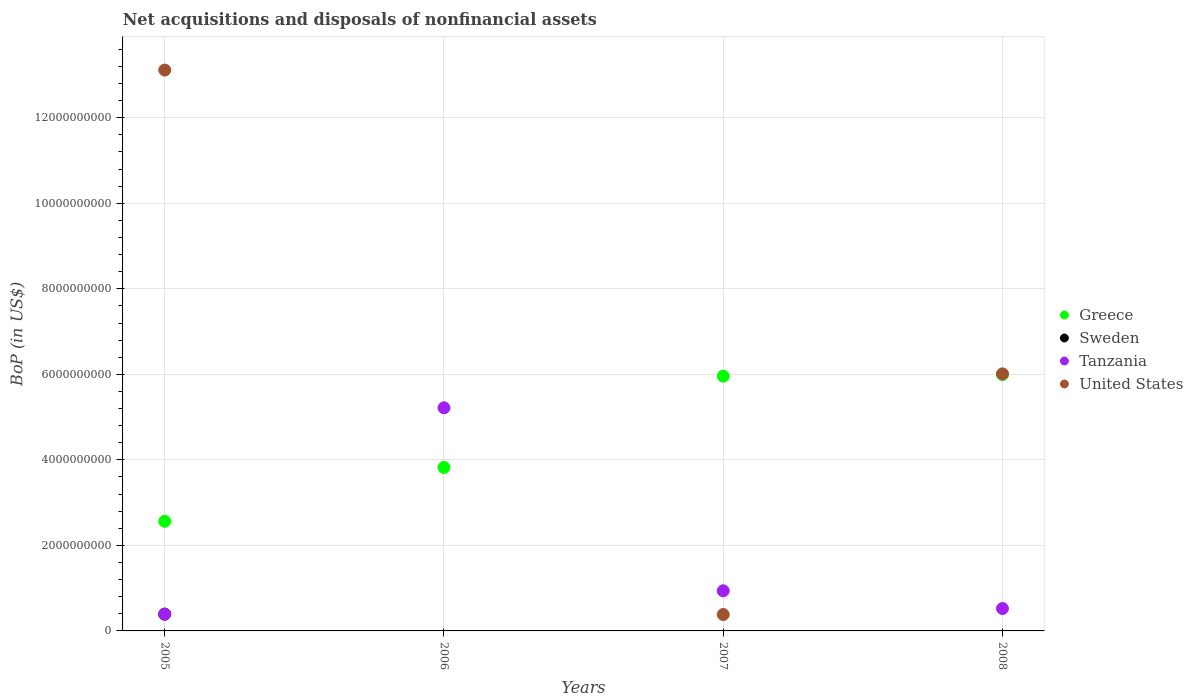How many different coloured dotlines are there?
Make the answer very short. 4. Is the number of dotlines equal to the number of legend labels?
Provide a succinct answer. No. What is the Balance of Payments in Greece in 2007?
Provide a succinct answer. 5.96e+09. Across all years, what is the maximum Balance of Payments in Tanzania?
Ensure brevity in your answer.  5.22e+09. Across all years, what is the minimum Balance of Payments in Sweden?
Your answer should be very brief. 0. In which year was the Balance of Payments in United States maximum?
Make the answer very short. 2005. What is the total Balance of Payments in Greece in the graph?
Your response must be concise. 1.83e+1. What is the difference between the Balance of Payments in Greece in 2006 and that in 2008?
Ensure brevity in your answer.  -2.17e+09. What is the difference between the Balance of Payments in Tanzania in 2006 and the Balance of Payments in Greece in 2007?
Provide a short and direct response. -7.39e+08. What is the average Balance of Payments in Greece per year?
Give a very brief answer. 4.58e+09. In the year 2008, what is the difference between the Balance of Payments in Greece and Balance of Payments in United States?
Your response must be concise. -1.59e+07. In how many years, is the Balance of Payments in Tanzania greater than 6800000000 US$?
Offer a very short reply. 0. What is the ratio of the Balance of Payments in Greece in 2005 to that in 2007?
Ensure brevity in your answer.  0.43. What is the difference between the highest and the second highest Balance of Payments in Greece?
Your response must be concise. 3.82e+07. What is the difference between the highest and the lowest Balance of Payments in United States?
Offer a very short reply. 1.31e+1. In how many years, is the Balance of Payments in Tanzania greater than the average Balance of Payments in Tanzania taken over all years?
Your response must be concise. 1. Is it the case that in every year, the sum of the Balance of Payments in Tanzania and Balance of Payments in Greece  is greater than the Balance of Payments in United States?
Offer a very short reply. No. Is the Balance of Payments in United States strictly greater than the Balance of Payments in Sweden over the years?
Offer a terse response. Yes. What is the difference between two consecutive major ticks on the Y-axis?
Provide a succinct answer. 2.00e+09. Where does the legend appear in the graph?
Provide a short and direct response. Center right. What is the title of the graph?
Offer a terse response. Net acquisitions and disposals of nonfinancial assets. What is the label or title of the Y-axis?
Offer a very short reply. BoP (in US$). What is the BoP (in US$) in Greece in 2005?
Offer a terse response. 2.56e+09. What is the BoP (in US$) in Sweden in 2005?
Keep it short and to the point. 3.92e+08. What is the BoP (in US$) of Tanzania in 2005?
Your response must be concise. 3.93e+08. What is the BoP (in US$) in United States in 2005?
Offer a terse response. 1.31e+1. What is the BoP (in US$) in Greece in 2006?
Make the answer very short. 3.82e+09. What is the BoP (in US$) in Sweden in 2006?
Offer a very short reply. 0. What is the BoP (in US$) in Tanzania in 2006?
Your answer should be very brief. 5.22e+09. What is the BoP (in US$) in United States in 2006?
Provide a short and direct response. 0. What is the BoP (in US$) of Greece in 2007?
Make the answer very short. 5.96e+09. What is the BoP (in US$) in Sweden in 2007?
Offer a very short reply. 0. What is the BoP (in US$) of Tanzania in 2007?
Your response must be concise. 9.39e+08. What is the BoP (in US$) in United States in 2007?
Offer a terse response. 3.84e+08. What is the BoP (in US$) in Greece in 2008?
Offer a terse response. 6.00e+09. What is the BoP (in US$) in Sweden in 2008?
Provide a short and direct response. 0. What is the BoP (in US$) in Tanzania in 2008?
Offer a terse response. 5.24e+08. What is the BoP (in US$) in United States in 2008?
Provide a succinct answer. 6.01e+09. Across all years, what is the maximum BoP (in US$) of Greece?
Make the answer very short. 6.00e+09. Across all years, what is the maximum BoP (in US$) of Sweden?
Your answer should be compact. 3.92e+08. Across all years, what is the maximum BoP (in US$) in Tanzania?
Offer a terse response. 5.22e+09. Across all years, what is the maximum BoP (in US$) of United States?
Offer a very short reply. 1.31e+1. Across all years, what is the minimum BoP (in US$) of Greece?
Your response must be concise. 2.56e+09. Across all years, what is the minimum BoP (in US$) in Tanzania?
Give a very brief answer. 3.93e+08. What is the total BoP (in US$) in Greece in the graph?
Give a very brief answer. 1.83e+1. What is the total BoP (in US$) in Sweden in the graph?
Your answer should be compact. 3.92e+08. What is the total BoP (in US$) of Tanzania in the graph?
Make the answer very short. 7.07e+09. What is the total BoP (in US$) of United States in the graph?
Your answer should be very brief. 1.95e+1. What is the difference between the BoP (in US$) of Greece in 2005 and that in 2006?
Make the answer very short. -1.26e+09. What is the difference between the BoP (in US$) of Tanzania in 2005 and that in 2006?
Make the answer very short. -4.82e+09. What is the difference between the BoP (in US$) of Greece in 2005 and that in 2007?
Your response must be concise. -3.39e+09. What is the difference between the BoP (in US$) of Tanzania in 2005 and that in 2007?
Offer a terse response. -5.45e+08. What is the difference between the BoP (in US$) in United States in 2005 and that in 2007?
Your answer should be compact. 1.27e+1. What is the difference between the BoP (in US$) in Greece in 2005 and that in 2008?
Provide a short and direct response. -3.43e+09. What is the difference between the BoP (in US$) of Tanzania in 2005 and that in 2008?
Offer a very short reply. -1.31e+08. What is the difference between the BoP (in US$) of United States in 2005 and that in 2008?
Provide a short and direct response. 7.10e+09. What is the difference between the BoP (in US$) of Greece in 2006 and that in 2007?
Your answer should be very brief. -2.14e+09. What is the difference between the BoP (in US$) in Tanzania in 2006 and that in 2007?
Give a very brief answer. 4.28e+09. What is the difference between the BoP (in US$) in Greece in 2006 and that in 2008?
Offer a very short reply. -2.17e+09. What is the difference between the BoP (in US$) in Tanzania in 2006 and that in 2008?
Make the answer very short. 4.69e+09. What is the difference between the BoP (in US$) of Greece in 2007 and that in 2008?
Give a very brief answer. -3.82e+07. What is the difference between the BoP (in US$) in Tanzania in 2007 and that in 2008?
Provide a succinct answer. 4.14e+08. What is the difference between the BoP (in US$) of United States in 2007 and that in 2008?
Your answer should be very brief. -5.63e+09. What is the difference between the BoP (in US$) of Greece in 2005 and the BoP (in US$) of Tanzania in 2006?
Your answer should be compact. -2.65e+09. What is the difference between the BoP (in US$) of Sweden in 2005 and the BoP (in US$) of Tanzania in 2006?
Make the answer very short. -4.83e+09. What is the difference between the BoP (in US$) in Greece in 2005 and the BoP (in US$) in Tanzania in 2007?
Your answer should be very brief. 1.62e+09. What is the difference between the BoP (in US$) in Greece in 2005 and the BoP (in US$) in United States in 2007?
Give a very brief answer. 2.18e+09. What is the difference between the BoP (in US$) in Sweden in 2005 and the BoP (in US$) in Tanzania in 2007?
Offer a terse response. -5.46e+08. What is the difference between the BoP (in US$) of Sweden in 2005 and the BoP (in US$) of United States in 2007?
Provide a short and direct response. 8.28e+06. What is the difference between the BoP (in US$) of Tanzania in 2005 and the BoP (in US$) of United States in 2007?
Your answer should be compact. 9.15e+06. What is the difference between the BoP (in US$) of Greece in 2005 and the BoP (in US$) of Tanzania in 2008?
Give a very brief answer. 2.04e+09. What is the difference between the BoP (in US$) in Greece in 2005 and the BoP (in US$) in United States in 2008?
Your response must be concise. -3.45e+09. What is the difference between the BoP (in US$) of Sweden in 2005 and the BoP (in US$) of Tanzania in 2008?
Provide a succinct answer. -1.32e+08. What is the difference between the BoP (in US$) of Sweden in 2005 and the BoP (in US$) of United States in 2008?
Make the answer very short. -5.62e+09. What is the difference between the BoP (in US$) of Tanzania in 2005 and the BoP (in US$) of United States in 2008?
Your response must be concise. -5.62e+09. What is the difference between the BoP (in US$) in Greece in 2006 and the BoP (in US$) in Tanzania in 2007?
Ensure brevity in your answer.  2.88e+09. What is the difference between the BoP (in US$) of Greece in 2006 and the BoP (in US$) of United States in 2007?
Ensure brevity in your answer.  3.44e+09. What is the difference between the BoP (in US$) in Tanzania in 2006 and the BoP (in US$) in United States in 2007?
Provide a short and direct response. 4.83e+09. What is the difference between the BoP (in US$) of Greece in 2006 and the BoP (in US$) of Tanzania in 2008?
Make the answer very short. 3.30e+09. What is the difference between the BoP (in US$) in Greece in 2006 and the BoP (in US$) in United States in 2008?
Your response must be concise. -2.19e+09. What is the difference between the BoP (in US$) in Tanzania in 2006 and the BoP (in US$) in United States in 2008?
Ensure brevity in your answer.  -7.93e+08. What is the difference between the BoP (in US$) in Greece in 2007 and the BoP (in US$) in Tanzania in 2008?
Ensure brevity in your answer.  5.43e+09. What is the difference between the BoP (in US$) of Greece in 2007 and the BoP (in US$) of United States in 2008?
Keep it short and to the point. -5.41e+07. What is the difference between the BoP (in US$) of Tanzania in 2007 and the BoP (in US$) of United States in 2008?
Give a very brief answer. -5.07e+09. What is the average BoP (in US$) of Greece per year?
Ensure brevity in your answer.  4.58e+09. What is the average BoP (in US$) in Sweden per year?
Provide a succinct answer. 9.81e+07. What is the average BoP (in US$) of Tanzania per year?
Your response must be concise. 1.77e+09. What is the average BoP (in US$) in United States per year?
Your answer should be very brief. 4.88e+09. In the year 2005, what is the difference between the BoP (in US$) in Greece and BoP (in US$) in Sweden?
Give a very brief answer. 2.17e+09. In the year 2005, what is the difference between the BoP (in US$) of Greece and BoP (in US$) of Tanzania?
Your response must be concise. 2.17e+09. In the year 2005, what is the difference between the BoP (in US$) of Greece and BoP (in US$) of United States?
Your response must be concise. -1.06e+1. In the year 2005, what is the difference between the BoP (in US$) in Sweden and BoP (in US$) in Tanzania?
Provide a short and direct response. -8.65e+05. In the year 2005, what is the difference between the BoP (in US$) of Sweden and BoP (in US$) of United States?
Ensure brevity in your answer.  -1.27e+1. In the year 2005, what is the difference between the BoP (in US$) in Tanzania and BoP (in US$) in United States?
Ensure brevity in your answer.  -1.27e+1. In the year 2006, what is the difference between the BoP (in US$) of Greece and BoP (in US$) of Tanzania?
Your answer should be very brief. -1.40e+09. In the year 2007, what is the difference between the BoP (in US$) of Greece and BoP (in US$) of Tanzania?
Offer a very short reply. 5.02e+09. In the year 2007, what is the difference between the BoP (in US$) in Greece and BoP (in US$) in United States?
Offer a very short reply. 5.57e+09. In the year 2007, what is the difference between the BoP (in US$) in Tanzania and BoP (in US$) in United States?
Offer a very short reply. 5.55e+08. In the year 2008, what is the difference between the BoP (in US$) in Greece and BoP (in US$) in Tanzania?
Make the answer very short. 5.47e+09. In the year 2008, what is the difference between the BoP (in US$) in Greece and BoP (in US$) in United States?
Offer a terse response. -1.59e+07. In the year 2008, what is the difference between the BoP (in US$) of Tanzania and BoP (in US$) of United States?
Provide a succinct answer. -5.49e+09. What is the ratio of the BoP (in US$) in Greece in 2005 to that in 2006?
Provide a short and direct response. 0.67. What is the ratio of the BoP (in US$) in Tanzania in 2005 to that in 2006?
Offer a terse response. 0.08. What is the ratio of the BoP (in US$) of Greece in 2005 to that in 2007?
Keep it short and to the point. 0.43. What is the ratio of the BoP (in US$) of Tanzania in 2005 to that in 2007?
Keep it short and to the point. 0.42. What is the ratio of the BoP (in US$) in United States in 2005 to that in 2007?
Your answer should be very brief. 34.15. What is the ratio of the BoP (in US$) of Greece in 2005 to that in 2008?
Give a very brief answer. 0.43. What is the ratio of the BoP (in US$) in United States in 2005 to that in 2008?
Provide a short and direct response. 2.18. What is the ratio of the BoP (in US$) in Greece in 2006 to that in 2007?
Your answer should be compact. 0.64. What is the ratio of the BoP (in US$) in Tanzania in 2006 to that in 2007?
Make the answer very short. 5.56. What is the ratio of the BoP (in US$) of Greece in 2006 to that in 2008?
Give a very brief answer. 0.64. What is the ratio of the BoP (in US$) in Tanzania in 2006 to that in 2008?
Your answer should be very brief. 9.95. What is the ratio of the BoP (in US$) in Tanzania in 2007 to that in 2008?
Ensure brevity in your answer.  1.79. What is the ratio of the BoP (in US$) of United States in 2007 to that in 2008?
Your answer should be compact. 0.06. What is the difference between the highest and the second highest BoP (in US$) in Greece?
Provide a short and direct response. 3.82e+07. What is the difference between the highest and the second highest BoP (in US$) of Tanzania?
Offer a terse response. 4.28e+09. What is the difference between the highest and the second highest BoP (in US$) in United States?
Provide a short and direct response. 7.10e+09. What is the difference between the highest and the lowest BoP (in US$) in Greece?
Provide a succinct answer. 3.43e+09. What is the difference between the highest and the lowest BoP (in US$) in Sweden?
Offer a very short reply. 3.92e+08. What is the difference between the highest and the lowest BoP (in US$) in Tanzania?
Your answer should be compact. 4.82e+09. What is the difference between the highest and the lowest BoP (in US$) in United States?
Offer a very short reply. 1.31e+1. 